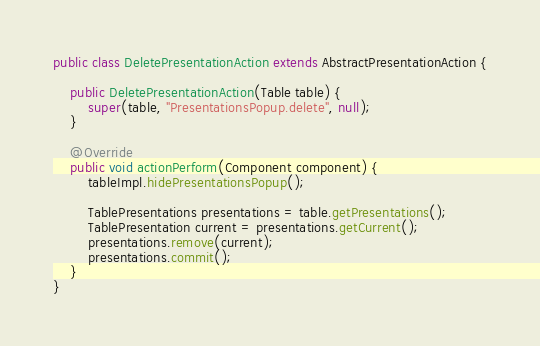<code> <loc_0><loc_0><loc_500><loc_500><_Java_>public class DeletePresentationAction extends AbstractPresentationAction {

    public DeletePresentationAction(Table table) {
        super(table, "PresentationsPopup.delete", null);
    }

    @Override
    public void actionPerform(Component component) {
        tableImpl.hidePresentationsPopup();

        TablePresentations presentations = table.getPresentations();
        TablePresentation current = presentations.getCurrent();
        presentations.remove(current);
        presentations.commit();
    }
}
</code> 